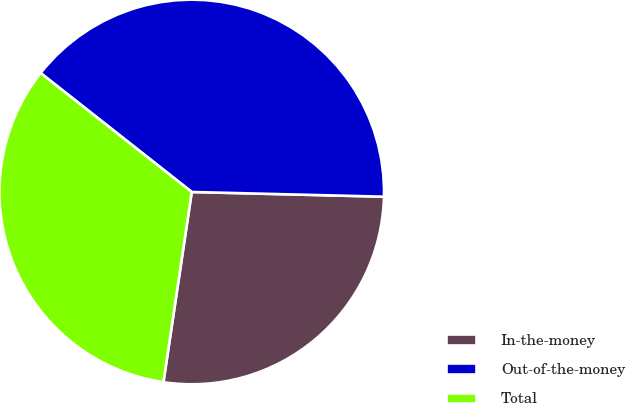<chart> <loc_0><loc_0><loc_500><loc_500><pie_chart><fcel>In-the-money<fcel>Out-of-the-money<fcel>Total<nl><fcel>26.96%<fcel>39.78%<fcel>33.26%<nl></chart> 